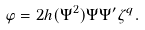Convert formula to latex. <formula><loc_0><loc_0><loc_500><loc_500>\varphi = 2 h ( \Psi ^ { 2 } ) \Psi \Psi ^ { \prime } \zeta ^ { q } .</formula> 